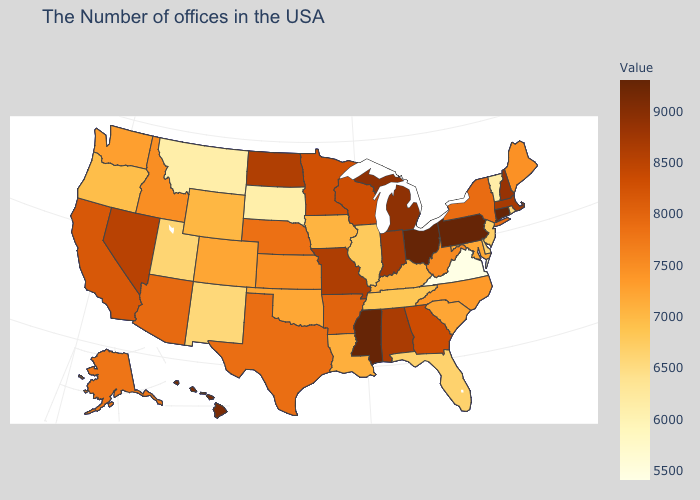Does Pennsylvania have the highest value in the USA?
Quick response, please. Yes. Which states have the lowest value in the USA?
Quick response, please. Virginia. Which states have the lowest value in the USA?
Keep it brief. Virginia. Does Virginia have the lowest value in the South?
Keep it brief. Yes. Among the states that border Wisconsin , which have the lowest value?
Be succinct. Illinois. Does Connecticut have the lowest value in the Northeast?
Keep it brief. No. Does Florida have the lowest value in the USA?
Be succinct. No. Which states have the lowest value in the South?
Be succinct. Virginia. 